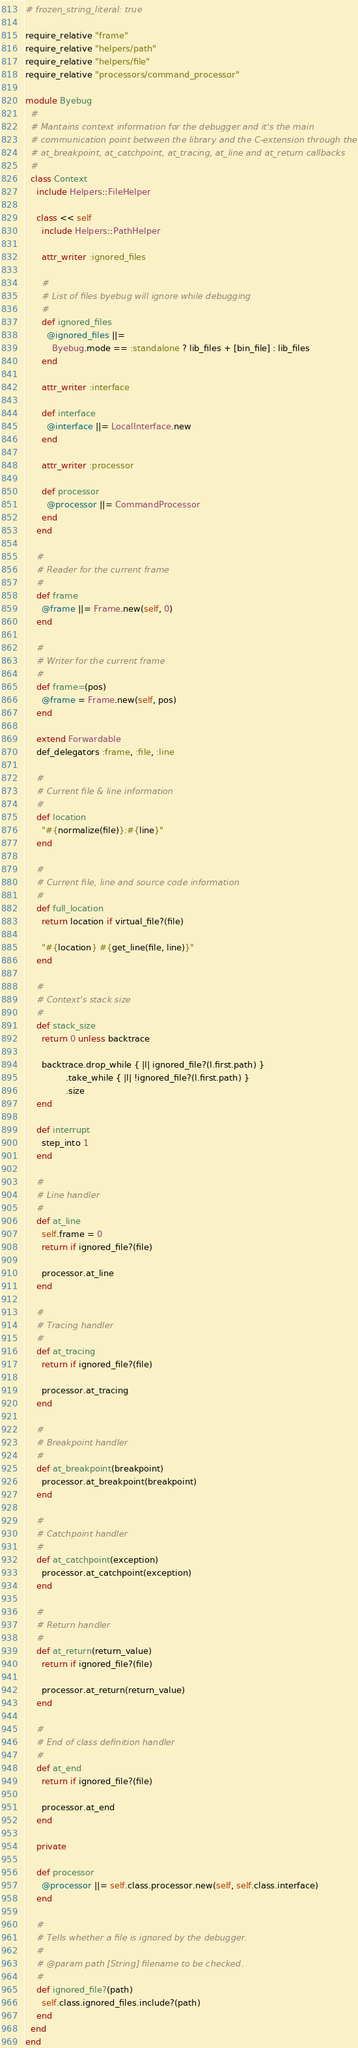<code> <loc_0><loc_0><loc_500><loc_500><_Ruby_># frozen_string_literal: true

require_relative "frame"
require_relative "helpers/path"
require_relative "helpers/file"
require_relative "processors/command_processor"

module Byebug
  #
  # Mantains context information for the debugger and it's the main
  # communication point between the library and the C-extension through the
  # at_breakpoint, at_catchpoint, at_tracing, at_line and at_return callbacks
  #
  class Context
    include Helpers::FileHelper

    class << self
      include Helpers::PathHelper

      attr_writer :ignored_files

      #
      # List of files byebug will ignore while debugging
      #
      def ignored_files
        @ignored_files ||=
          Byebug.mode == :standalone ? lib_files + [bin_file] : lib_files
      end

      attr_writer :interface

      def interface
        @interface ||= LocalInterface.new
      end

      attr_writer :processor

      def processor
        @processor ||= CommandProcessor
      end
    end

    #
    # Reader for the current frame
    #
    def frame
      @frame ||= Frame.new(self, 0)
    end

    #
    # Writer for the current frame
    #
    def frame=(pos)
      @frame = Frame.new(self, pos)
    end

    extend Forwardable
    def_delegators :frame, :file, :line

    #
    # Current file & line information
    #
    def location
      "#{normalize(file)}:#{line}"
    end

    #
    # Current file, line and source code information
    #
    def full_location
      return location if virtual_file?(file)

      "#{location} #{get_line(file, line)}"
    end

    #
    # Context's stack size
    #
    def stack_size
      return 0 unless backtrace

      backtrace.drop_while { |l| ignored_file?(l.first.path) }
               .take_while { |l| !ignored_file?(l.first.path) }
               .size
    end

    def interrupt
      step_into 1
    end

    #
    # Line handler
    #
    def at_line
      self.frame = 0
      return if ignored_file?(file)

      processor.at_line
    end

    #
    # Tracing handler
    #
    def at_tracing
      return if ignored_file?(file)

      processor.at_tracing
    end

    #
    # Breakpoint handler
    #
    def at_breakpoint(breakpoint)
      processor.at_breakpoint(breakpoint)
    end

    #
    # Catchpoint handler
    #
    def at_catchpoint(exception)
      processor.at_catchpoint(exception)
    end

    #
    # Return handler
    #
    def at_return(return_value)
      return if ignored_file?(file)

      processor.at_return(return_value)
    end

    #
    # End of class definition handler
    #
    def at_end
      return if ignored_file?(file)

      processor.at_end
    end

    private

    def processor
      @processor ||= self.class.processor.new(self, self.class.interface)
    end

    #
    # Tells whether a file is ignored by the debugger.
    #
    # @param path [String] filename to be checked.
    #
    def ignored_file?(path)
      self.class.ignored_files.include?(path)
    end
  end
end
</code> 